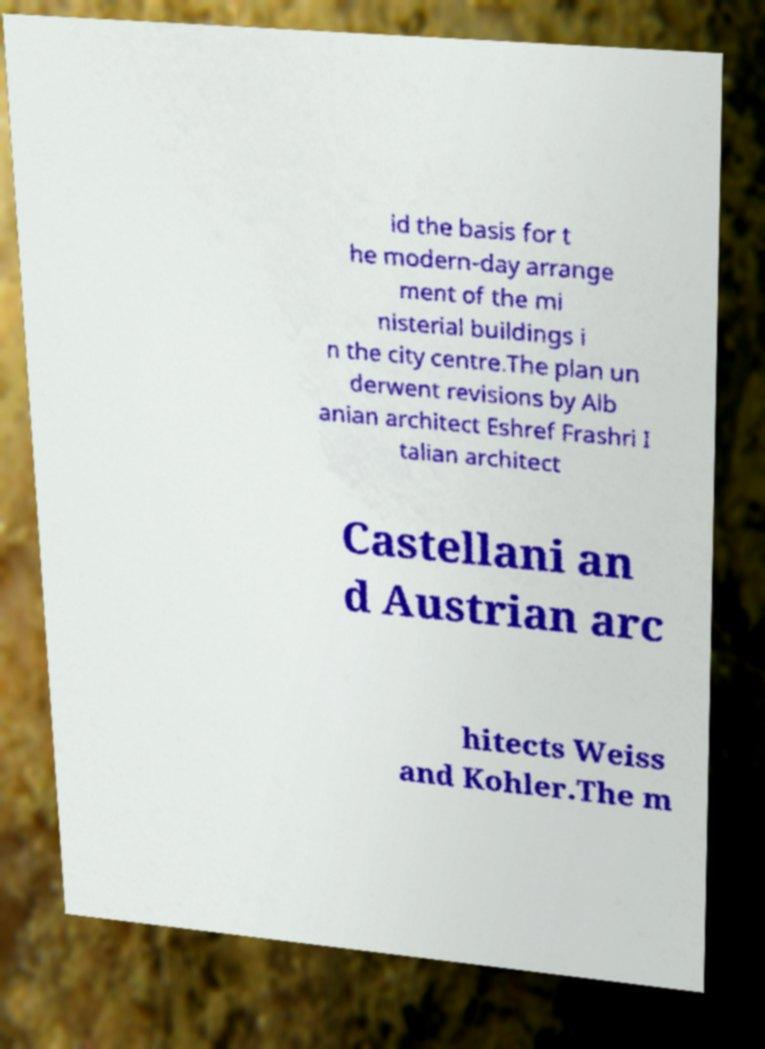Please identify and transcribe the text found in this image. id the basis for t he modern-day arrange ment of the mi nisterial buildings i n the city centre.The plan un derwent revisions by Alb anian architect Eshref Frashri I talian architect Castellani an d Austrian arc hitects Weiss and Kohler.The m 